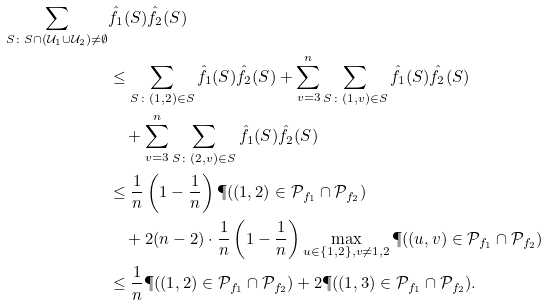<formula> <loc_0><loc_0><loc_500><loc_500>\sum _ { S \colon S \cap ( \mathcal { U } _ { 1 } \cup \mathcal { U } _ { 2 } ) \neq \emptyset } & \hat { f } _ { 1 } ( S ) \hat { f } _ { 2 } ( S ) \\ & \leq \sum _ { S \colon ( 1 , 2 ) \in S } \hat { f } _ { 1 } ( S ) \hat { f } _ { 2 } ( S ) + \sum _ { v = 3 } ^ { n } \sum _ { S \colon ( 1 , v ) \in S } \hat { f } _ { 1 } ( S ) \hat { f } _ { 2 } ( S ) \\ & \quad + \sum _ { v = 3 } ^ { n } \sum _ { S \colon ( 2 , v ) \in S } \hat { f } _ { 1 } ( S ) \hat { f } _ { 2 } ( S ) \\ & \leq \frac { 1 } { n } \left ( 1 - \frac { 1 } { n } \right ) \P ( ( 1 , 2 ) \in \mathcal { P } _ { f _ { 1 } } \cap \mathcal { P } _ { f _ { 2 } } ) \\ & \quad + 2 ( n - 2 ) \cdot \frac { 1 } { n } \left ( 1 - \frac { 1 } { n } \right ) \max _ { u \in \{ 1 , 2 \} , v \neq 1 , 2 } \P ( ( u , v ) \in \mathcal { P } _ { f _ { 1 } } \cap \mathcal { P } _ { f _ { 2 } } ) \\ & \leq \frac { 1 } { n } \P ( ( 1 , 2 ) \in \mathcal { P } _ { f _ { 1 } } \cap \mathcal { P } _ { f _ { 2 } } ) + 2 \P ( ( 1 , 3 ) \in \mathcal { P } _ { f _ { 1 } } \cap \mathcal { P } _ { f _ { 2 } } ) .</formula> 